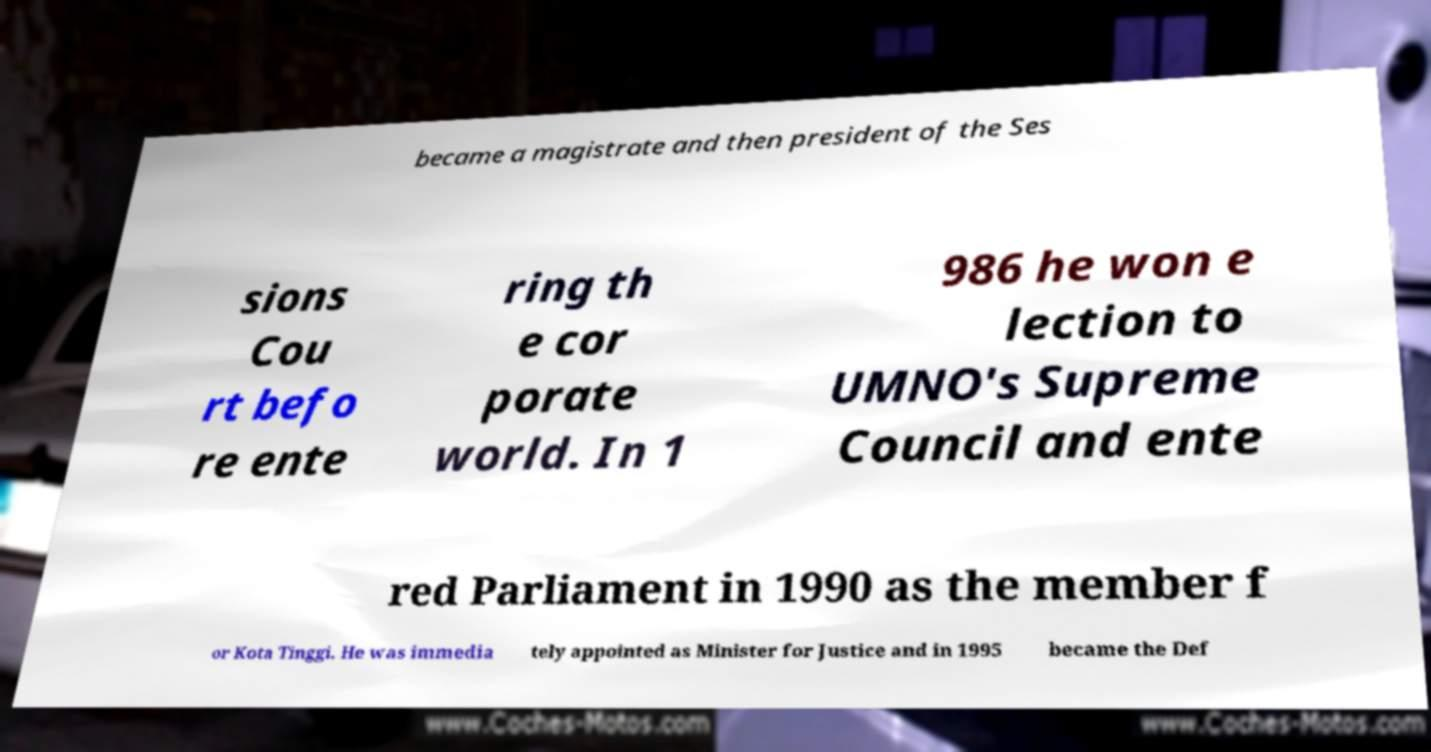What messages or text are displayed in this image? I need them in a readable, typed format. became a magistrate and then president of the Ses sions Cou rt befo re ente ring th e cor porate world. In 1 986 he won e lection to UMNO's Supreme Council and ente red Parliament in 1990 as the member f or Kota Tinggi. He was immedia tely appointed as Minister for Justice and in 1995 became the Def 